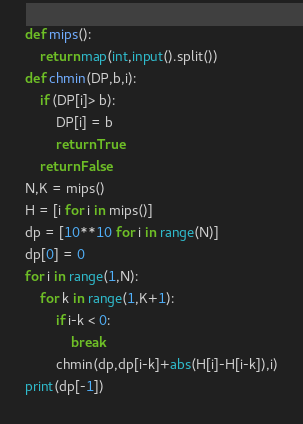<code> <loc_0><loc_0><loc_500><loc_500><_Python_>def mips():
    return map(int,input().split())
def chmin(DP,b,i):
    if (DP[i]> b):
        DP[i] = b
        return True
    return False
N,K = mips()
H = [i for i in mips()]
dp = [10**10 for i in range(N)]
dp[0] = 0
for i in range(1,N):
    for k in range(1,K+1):
        if i-k < 0:
            break
        chmin(dp,dp[i-k]+abs(H[i]-H[i-k]),i)
print(dp[-1])</code> 